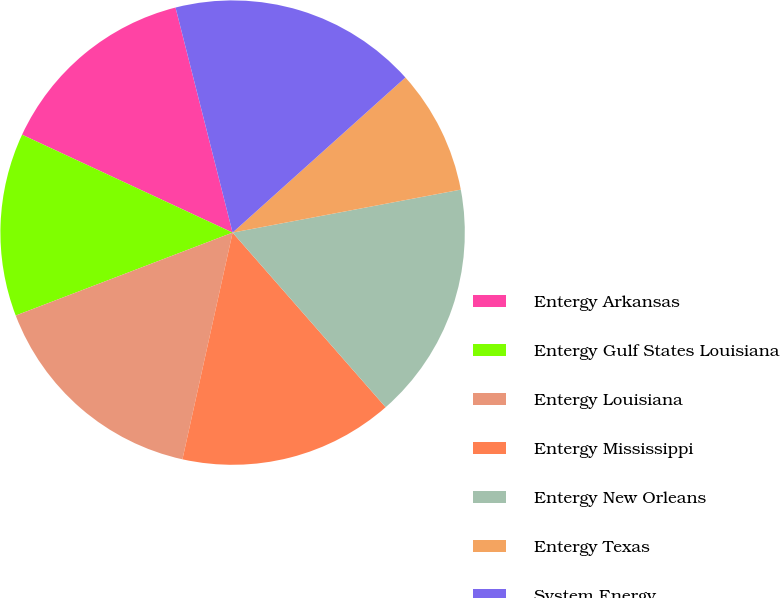Convert chart to OTSL. <chart><loc_0><loc_0><loc_500><loc_500><pie_chart><fcel>Entergy Arkansas<fcel>Entergy Gulf States Louisiana<fcel>Entergy Louisiana<fcel>Entergy Mississippi<fcel>Entergy New Orleans<fcel>Entergy Texas<fcel>System Energy<nl><fcel>14.12%<fcel>12.74%<fcel>15.72%<fcel>14.92%<fcel>16.51%<fcel>8.68%<fcel>17.31%<nl></chart> 